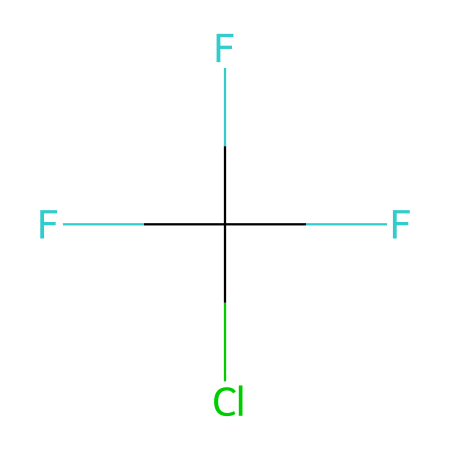What is the total number of halogen atoms in this molecule? The chemical structure shows one chlorine (Cl) and three fluorine (F) atoms, which are both halogens. Therefore, counting these halogen atoms gives a total of four.
Answer: four How many carbon atoms are present in this chemical? The SMILES representation indicates that there is one carbon (C) atom in the structure, as represented by the letter 'C'.
Answer: one What type of bonding is primarily involved in this molecule? The molecular composition includes single bonds between carbon and fluorine as well as chlorine atoms. Thus, the primary bonding type is covalent.
Answer: covalent Which halogen in this molecule has the highest number of atoms? The structure contains three fluorine atoms (F) and one chlorine atom (Cl). Since three is higher than one, fluorine is the halogen that appears in greatest quantity.
Answer: fluorine Does this molecule have any double bonds? In the given structure, there are only single bonds connecting the carbon to the fluorine and chlorine atoms. There are no double bonds present.
Answer: no What molecular property might this chemical possess due to the presence of chlorine? The presence of chlorine in this structure can contribute to the chemical's potential as a refrigerant, often related to its ability to absorb heat and subsequently release it.
Answer: refrigerant 